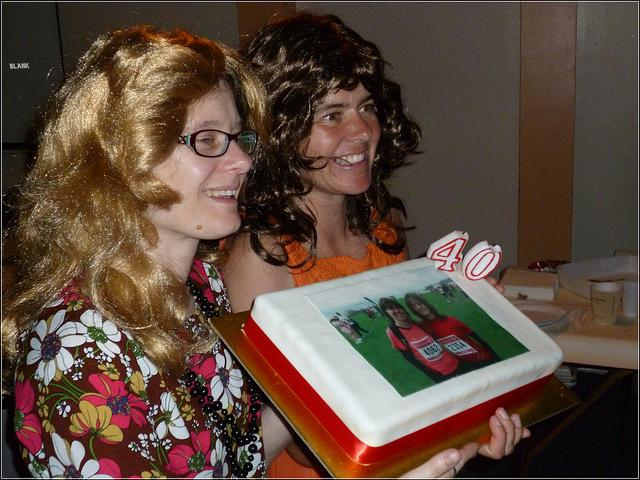How old is the birthday girl? Please explain your reasoning. 40. The candles on the cake indicate her age. 